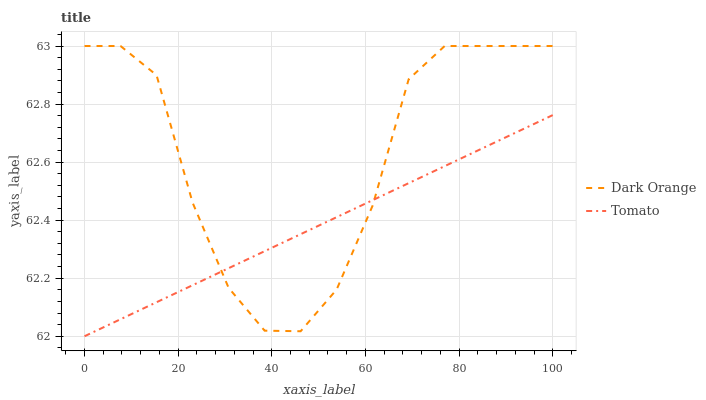Does Tomato have the minimum area under the curve?
Answer yes or no. Yes. Does Dark Orange have the maximum area under the curve?
Answer yes or no. Yes. Does Dark Orange have the minimum area under the curve?
Answer yes or no. No. Is Tomato the smoothest?
Answer yes or no. Yes. Is Dark Orange the roughest?
Answer yes or no. Yes. Is Dark Orange the smoothest?
Answer yes or no. No. Does Tomato have the lowest value?
Answer yes or no. Yes. Does Dark Orange have the lowest value?
Answer yes or no. No. Does Dark Orange have the highest value?
Answer yes or no. Yes. Does Dark Orange intersect Tomato?
Answer yes or no. Yes. Is Dark Orange less than Tomato?
Answer yes or no. No. Is Dark Orange greater than Tomato?
Answer yes or no. No. 